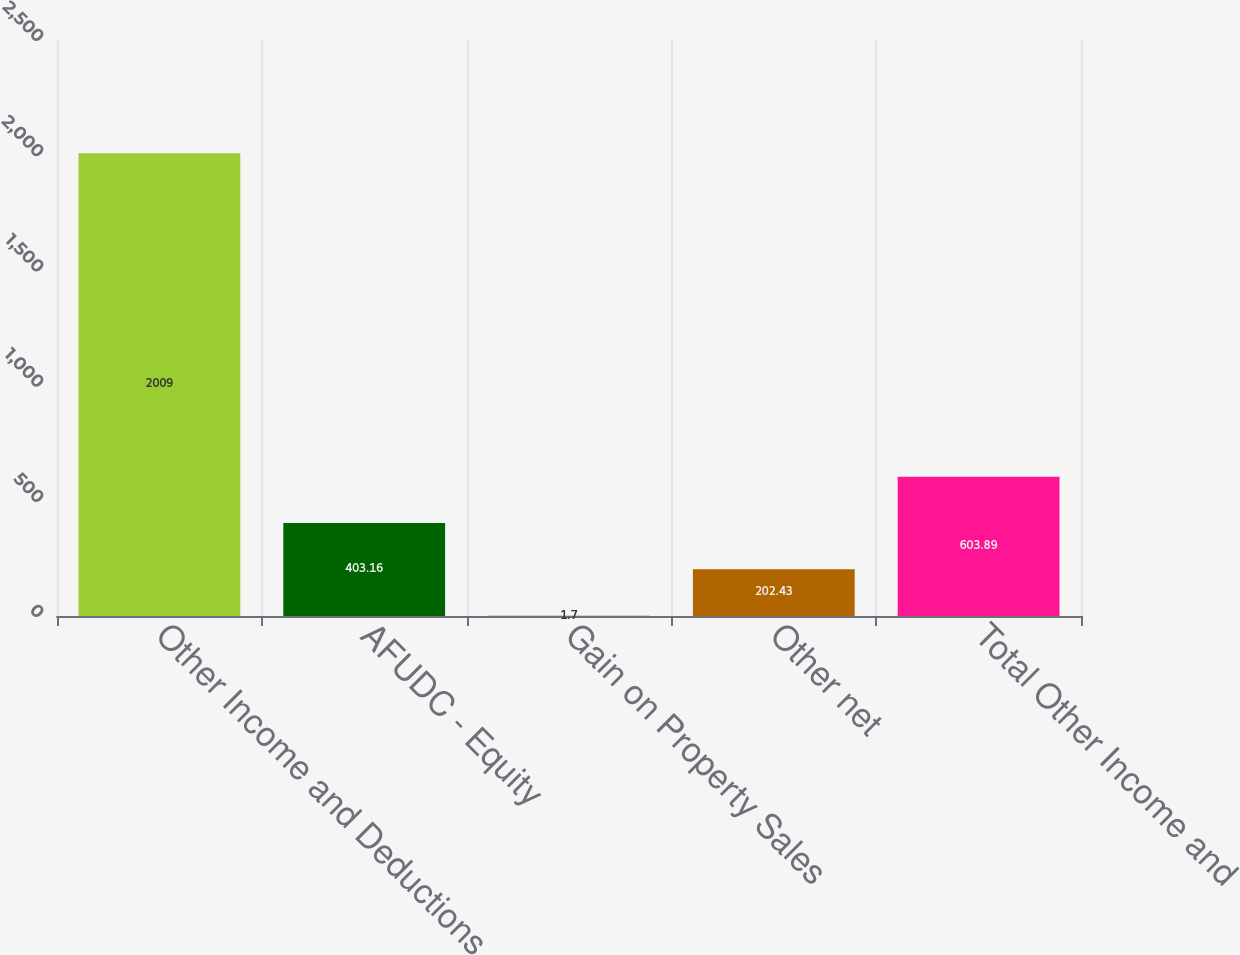<chart> <loc_0><loc_0><loc_500><loc_500><bar_chart><fcel>Other Income and Deductions<fcel>AFUDC - Equity<fcel>Gain on Property Sales<fcel>Other net<fcel>Total Other Income and<nl><fcel>2009<fcel>403.16<fcel>1.7<fcel>202.43<fcel>603.89<nl></chart> 